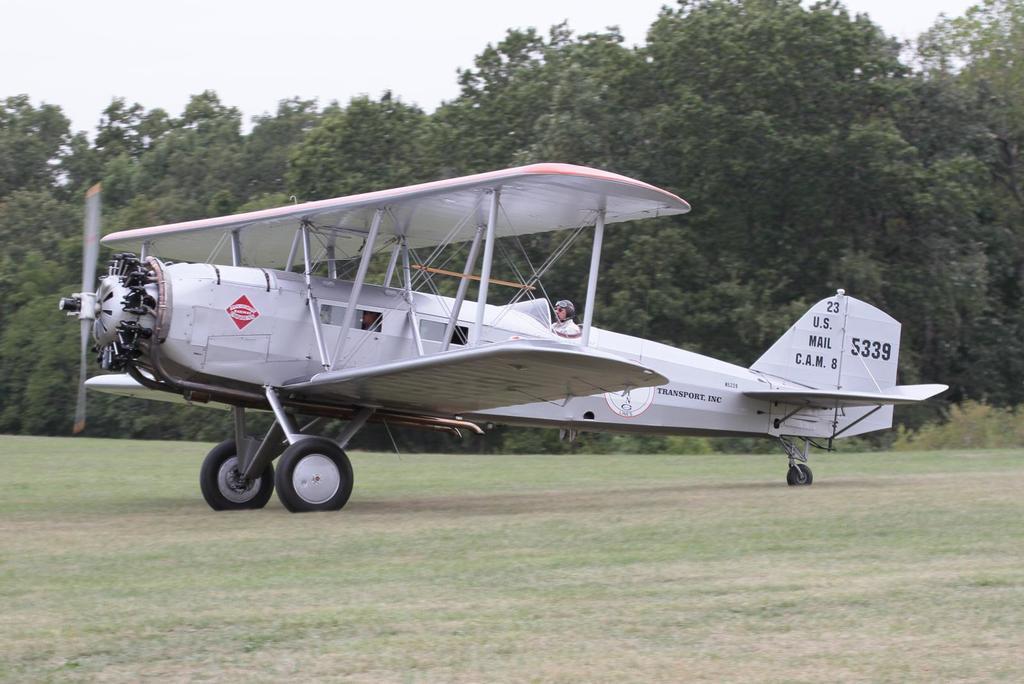Describe this image in one or two sentences. In this image I can see an aeroplane and person inside. It is in white color. Back I can see trees. The sky is in white color. 